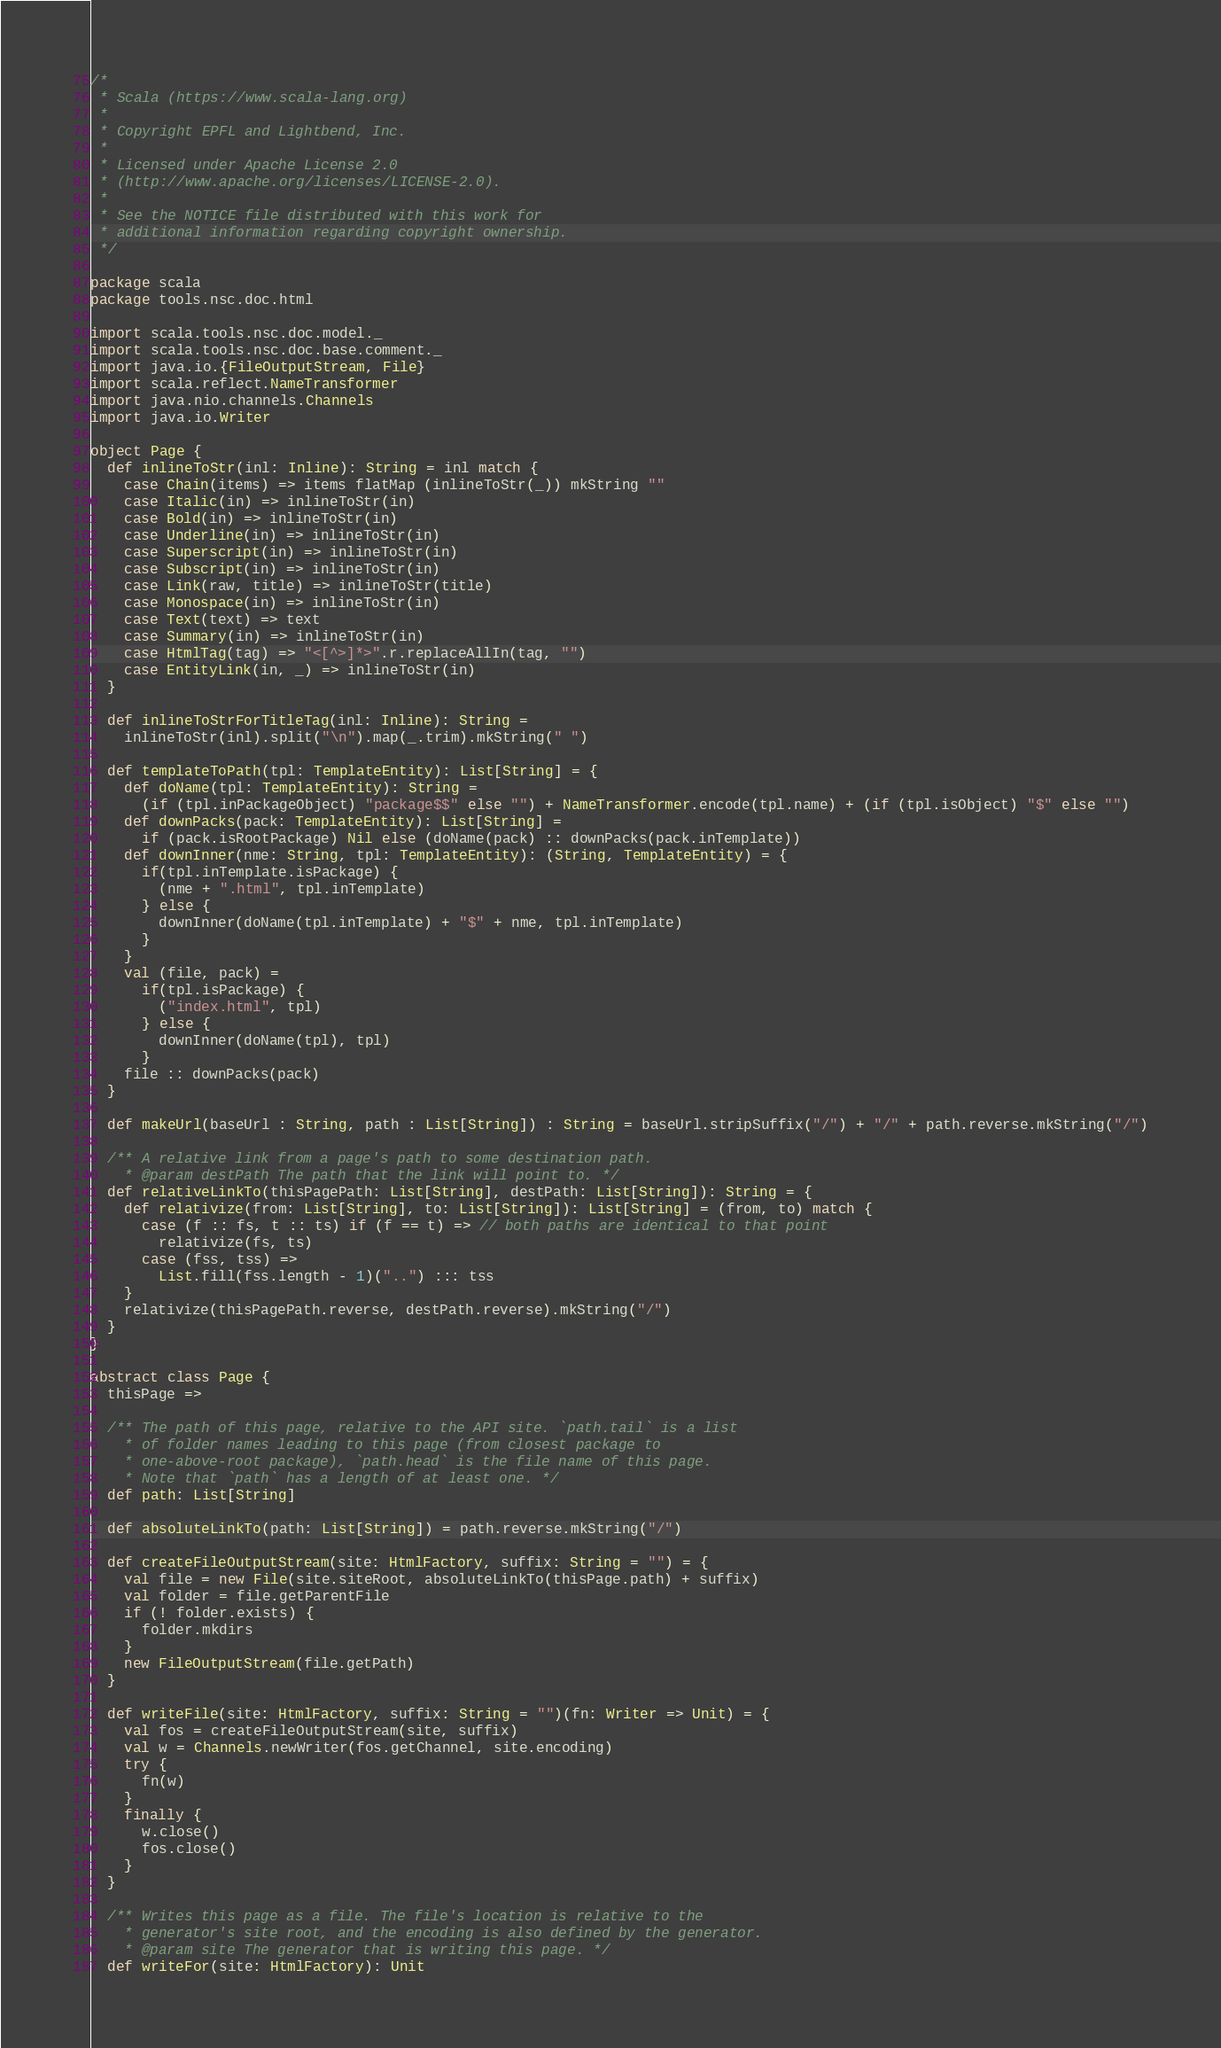Convert code to text. <code><loc_0><loc_0><loc_500><loc_500><_Scala_>/*
 * Scala (https://www.scala-lang.org)
 *
 * Copyright EPFL and Lightbend, Inc.
 *
 * Licensed under Apache License 2.0
 * (http://www.apache.org/licenses/LICENSE-2.0).
 *
 * See the NOTICE file distributed with this work for
 * additional information regarding copyright ownership.
 */

package scala
package tools.nsc.doc.html

import scala.tools.nsc.doc.model._
import scala.tools.nsc.doc.base.comment._
import java.io.{FileOutputStream, File}
import scala.reflect.NameTransformer
import java.nio.channels.Channels
import java.io.Writer

object Page {
  def inlineToStr(inl: Inline): String = inl match {
    case Chain(items) => items flatMap (inlineToStr(_)) mkString ""
    case Italic(in) => inlineToStr(in)
    case Bold(in) => inlineToStr(in)
    case Underline(in) => inlineToStr(in)
    case Superscript(in) => inlineToStr(in)
    case Subscript(in) => inlineToStr(in)
    case Link(raw, title) => inlineToStr(title)
    case Monospace(in) => inlineToStr(in)
    case Text(text) => text
    case Summary(in) => inlineToStr(in)
    case HtmlTag(tag) => "<[^>]*>".r.replaceAllIn(tag, "")
    case EntityLink(in, _) => inlineToStr(in)
  }

  def inlineToStrForTitleTag(inl: Inline): String =
    inlineToStr(inl).split("\n").map(_.trim).mkString(" ")

  def templateToPath(tpl: TemplateEntity): List[String] = {
    def doName(tpl: TemplateEntity): String =
      (if (tpl.inPackageObject) "package$$" else "") + NameTransformer.encode(tpl.name) + (if (tpl.isObject) "$" else "")
    def downPacks(pack: TemplateEntity): List[String] =
      if (pack.isRootPackage) Nil else (doName(pack) :: downPacks(pack.inTemplate))
    def downInner(nme: String, tpl: TemplateEntity): (String, TemplateEntity) = {
      if(tpl.inTemplate.isPackage) {
        (nme + ".html", tpl.inTemplate)
      } else {
        downInner(doName(tpl.inTemplate) + "$" + nme, tpl.inTemplate)
      }
    }
    val (file, pack) =
      if(tpl.isPackage) {
        ("index.html", tpl)
      } else {
        downInner(doName(tpl), tpl)
      }
    file :: downPacks(pack)
  }

  def makeUrl(baseUrl : String, path : List[String]) : String = baseUrl.stripSuffix("/") + "/" + path.reverse.mkString("/")

  /** A relative link from a page's path to some destination path.
    * @param destPath The path that the link will point to. */
  def relativeLinkTo(thisPagePath: List[String], destPath: List[String]): String = {
    def relativize(from: List[String], to: List[String]): List[String] = (from, to) match {
      case (f :: fs, t :: ts) if (f == t) => // both paths are identical to that point
        relativize(fs, ts)
      case (fss, tss) =>
        List.fill(fss.length - 1)("..") ::: tss
    }
    relativize(thisPagePath.reverse, destPath.reverse).mkString("/")
  }
}

abstract class Page {
  thisPage =>

  /** The path of this page, relative to the API site. `path.tail` is a list
    * of folder names leading to this page (from closest package to
    * one-above-root package), `path.head` is the file name of this page.
    * Note that `path` has a length of at least one. */
  def path: List[String]

  def absoluteLinkTo(path: List[String]) = path.reverse.mkString("/")

  def createFileOutputStream(site: HtmlFactory, suffix: String = "") = {
    val file = new File(site.siteRoot, absoluteLinkTo(thisPage.path) + suffix)
    val folder = file.getParentFile
    if (! folder.exists) {
      folder.mkdirs
    }
    new FileOutputStream(file.getPath)
  }

  def writeFile(site: HtmlFactory, suffix: String = "")(fn: Writer => Unit) = {
    val fos = createFileOutputStream(site, suffix)
    val w = Channels.newWriter(fos.getChannel, site.encoding)
    try {
      fn(w)
    }
    finally {
      w.close()
      fos.close()
    }
  }

  /** Writes this page as a file. The file's location is relative to the
    * generator's site root, and the encoding is also defined by the generator.
    * @param site The generator that is writing this page. */
  def writeFor(site: HtmlFactory): Unit
</code> 